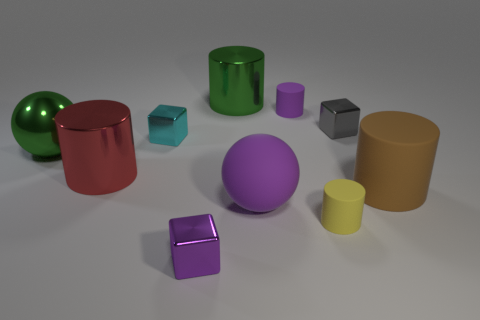What materials do these objects appear to be made of, and how can you tell? The objects seem to be made from materials with varying reflectivity and textures indicative of metals and plastics. The shiny surfaces suggest metallic composition, while the matte and slightly less reflective surfaces suggest plastics or rubbers. 